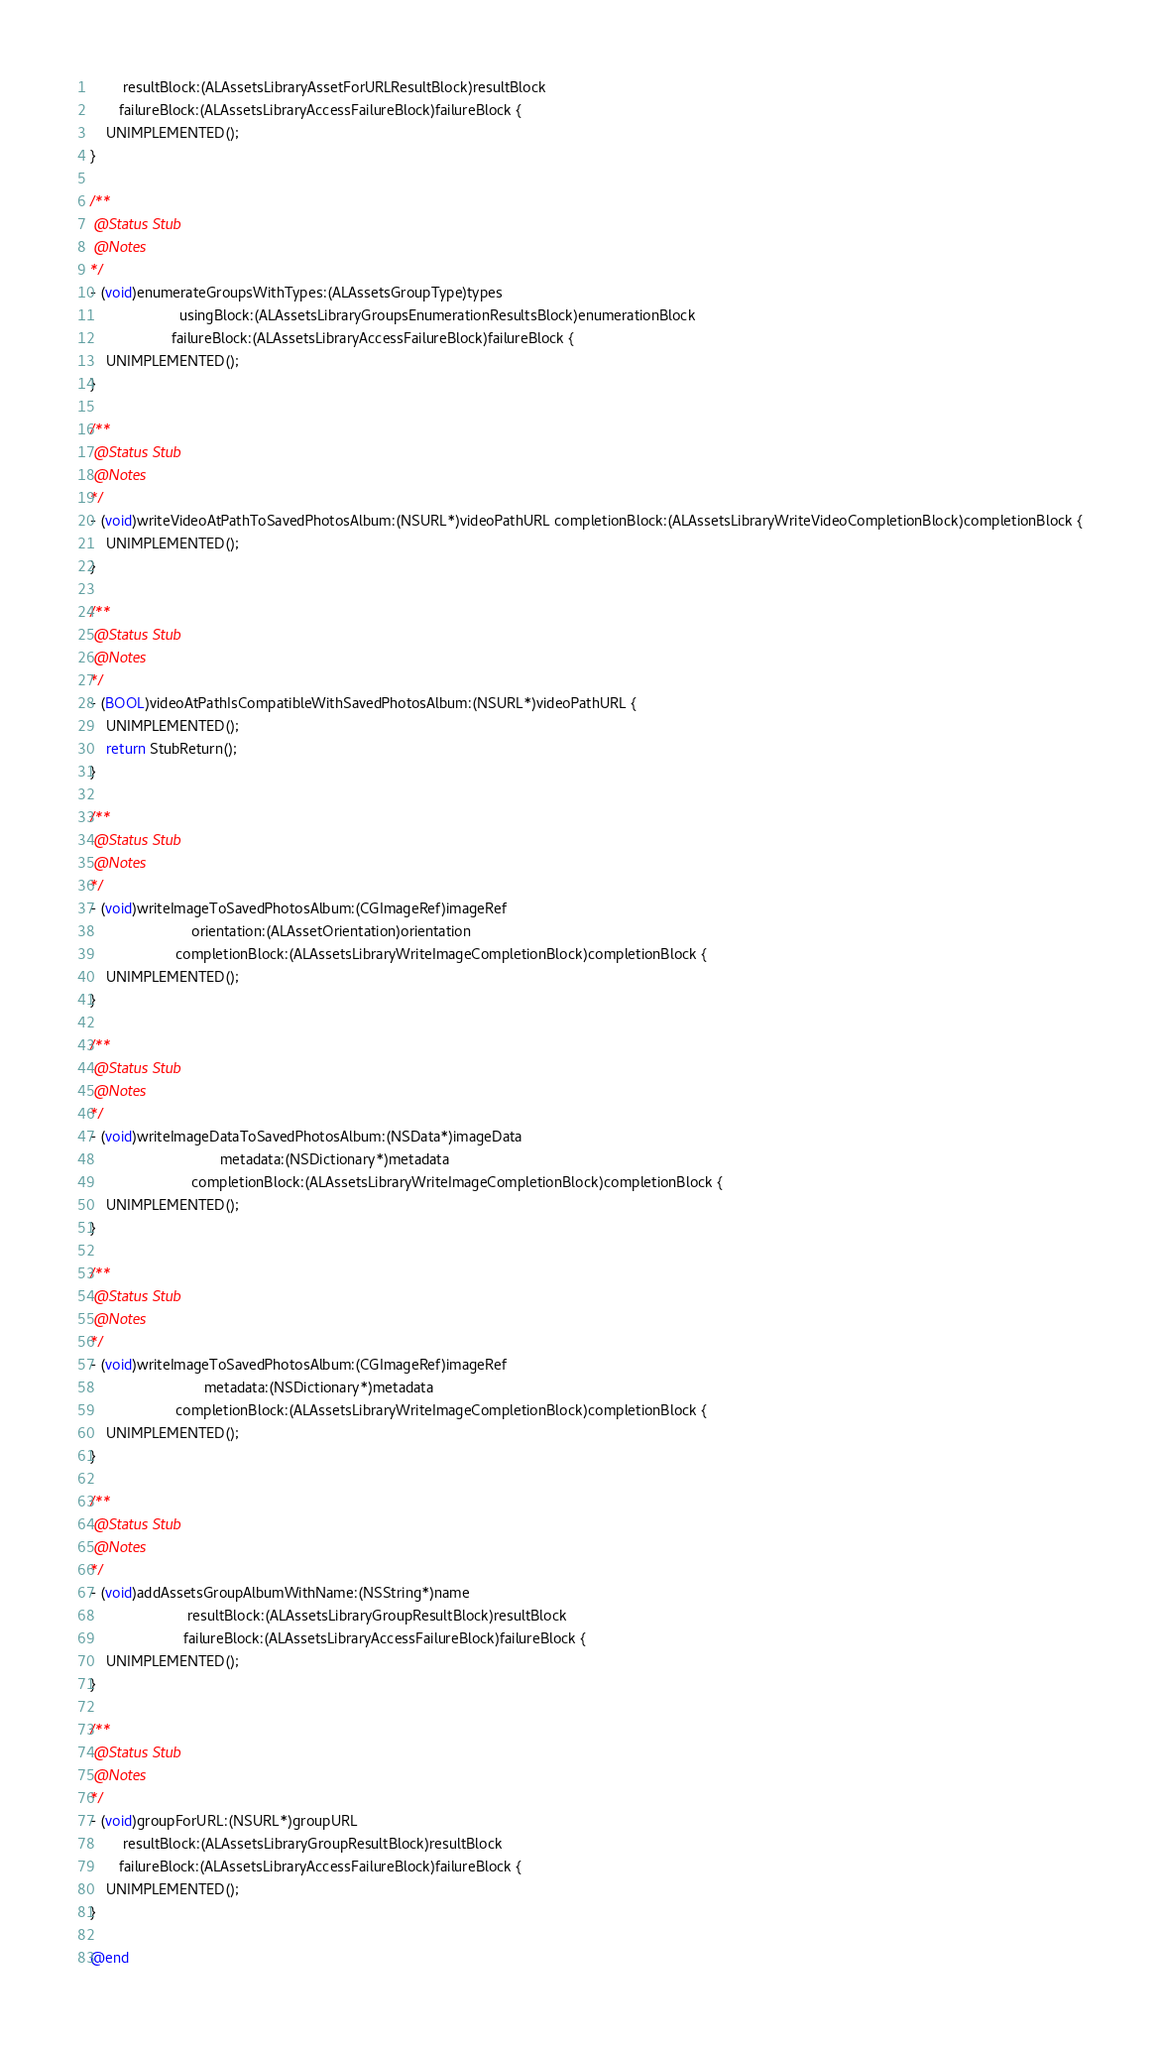<code> <loc_0><loc_0><loc_500><loc_500><_ObjectiveC_>        resultBlock:(ALAssetsLibraryAssetForURLResultBlock)resultBlock
       failureBlock:(ALAssetsLibraryAccessFailureBlock)failureBlock {
    UNIMPLEMENTED();
}

/**
 @Status Stub
 @Notes
*/
- (void)enumerateGroupsWithTypes:(ALAssetsGroupType)types
                      usingBlock:(ALAssetsLibraryGroupsEnumerationResultsBlock)enumerationBlock
                    failureBlock:(ALAssetsLibraryAccessFailureBlock)failureBlock {
    UNIMPLEMENTED();
}

/**
 @Status Stub
 @Notes
*/
- (void)writeVideoAtPathToSavedPhotosAlbum:(NSURL*)videoPathURL completionBlock:(ALAssetsLibraryWriteVideoCompletionBlock)completionBlock {
    UNIMPLEMENTED();
}

/**
 @Status Stub
 @Notes
*/
- (BOOL)videoAtPathIsCompatibleWithSavedPhotosAlbum:(NSURL*)videoPathURL {
    UNIMPLEMENTED();
    return StubReturn();
}

/**
 @Status Stub
 @Notes
*/
- (void)writeImageToSavedPhotosAlbum:(CGImageRef)imageRef
                         orientation:(ALAssetOrientation)orientation
                     completionBlock:(ALAssetsLibraryWriteImageCompletionBlock)completionBlock {
    UNIMPLEMENTED();
}

/**
 @Status Stub
 @Notes
*/
- (void)writeImageDataToSavedPhotosAlbum:(NSData*)imageData
                                metadata:(NSDictionary*)metadata
                         completionBlock:(ALAssetsLibraryWriteImageCompletionBlock)completionBlock {
    UNIMPLEMENTED();
}

/**
 @Status Stub
 @Notes
*/
- (void)writeImageToSavedPhotosAlbum:(CGImageRef)imageRef
                            metadata:(NSDictionary*)metadata
                     completionBlock:(ALAssetsLibraryWriteImageCompletionBlock)completionBlock {
    UNIMPLEMENTED();
}

/**
 @Status Stub
 @Notes
*/
- (void)addAssetsGroupAlbumWithName:(NSString*)name
                        resultBlock:(ALAssetsLibraryGroupResultBlock)resultBlock
                       failureBlock:(ALAssetsLibraryAccessFailureBlock)failureBlock {
    UNIMPLEMENTED();
}

/**
 @Status Stub
 @Notes
*/
- (void)groupForURL:(NSURL*)groupURL
        resultBlock:(ALAssetsLibraryGroupResultBlock)resultBlock
       failureBlock:(ALAssetsLibraryAccessFailureBlock)failureBlock {
    UNIMPLEMENTED();
}

@end
</code> 